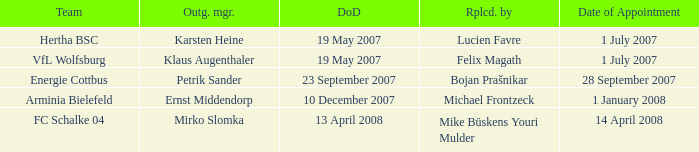When was the appointment date for VFL Wolfsburg? 1 July 2007. 